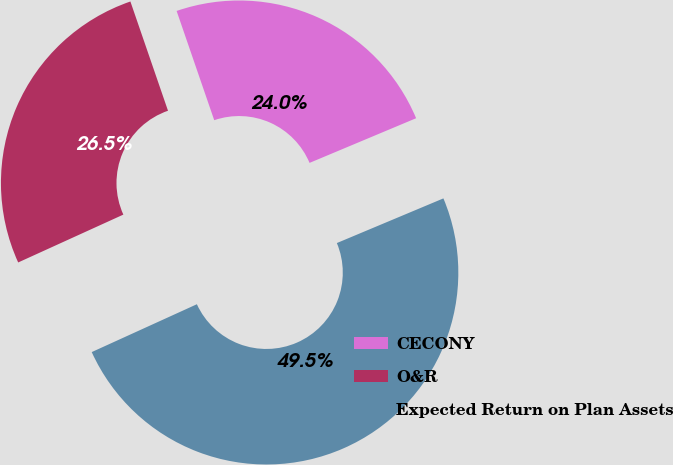Convert chart. <chart><loc_0><loc_0><loc_500><loc_500><pie_chart><fcel>CECONY<fcel>O&R<fcel>Expected Return on Plan Assets<nl><fcel>23.96%<fcel>26.52%<fcel>49.52%<nl></chart> 